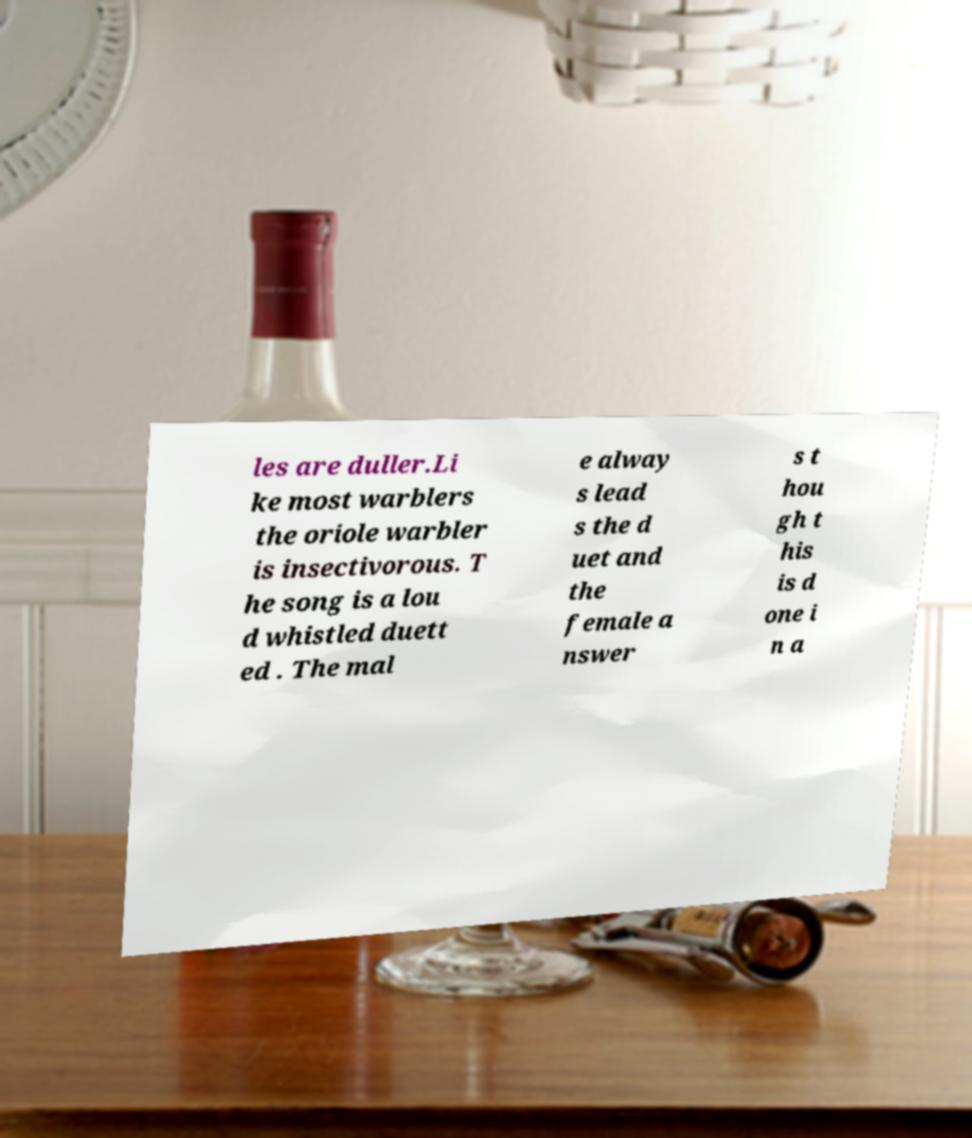Can you read and provide the text displayed in the image?This photo seems to have some interesting text. Can you extract and type it out for me? les are duller.Li ke most warblers the oriole warbler is insectivorous. T he song is a lou d whistled duett ed . The mal e alway s lead s the d uet and the female a nswer s t hou gh t his is d one i n a 